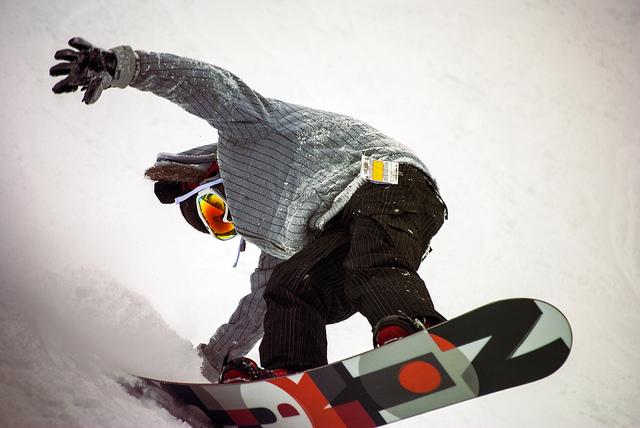Is it sunny?
Quick response, please. Yes. Are they going to fall or land correctly?
Quick response, please. Land correctly. What sport is this?
Give a very brief answer. Snowboarding. 